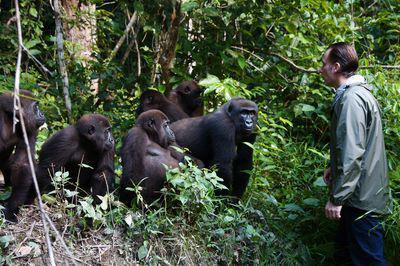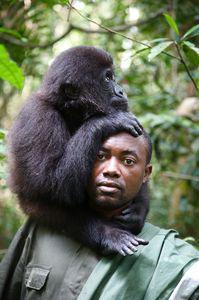The first image is the image on the left, the second image is the image on the right. Analyze the images presented: Is the assertion "The gorilla in the right image rests its hand against part of its own body." valid? Answer yes or no. No. 